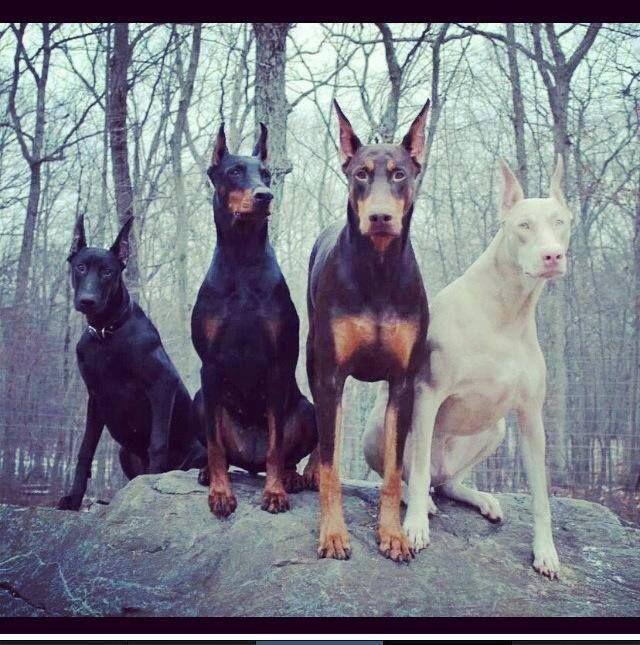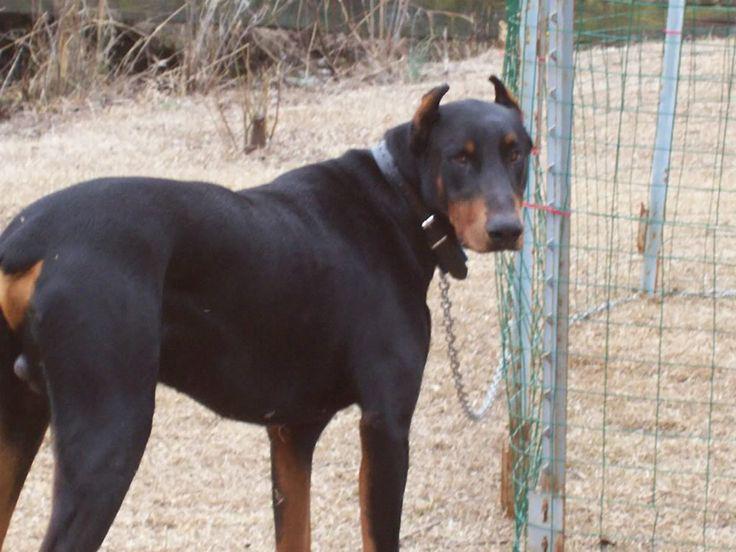The first image is the image on the left, the second image is the image on the right. Assess this claim about the two images: "The right image contains exactly two dogs.". Correct or not? Answer yes or no. No. 